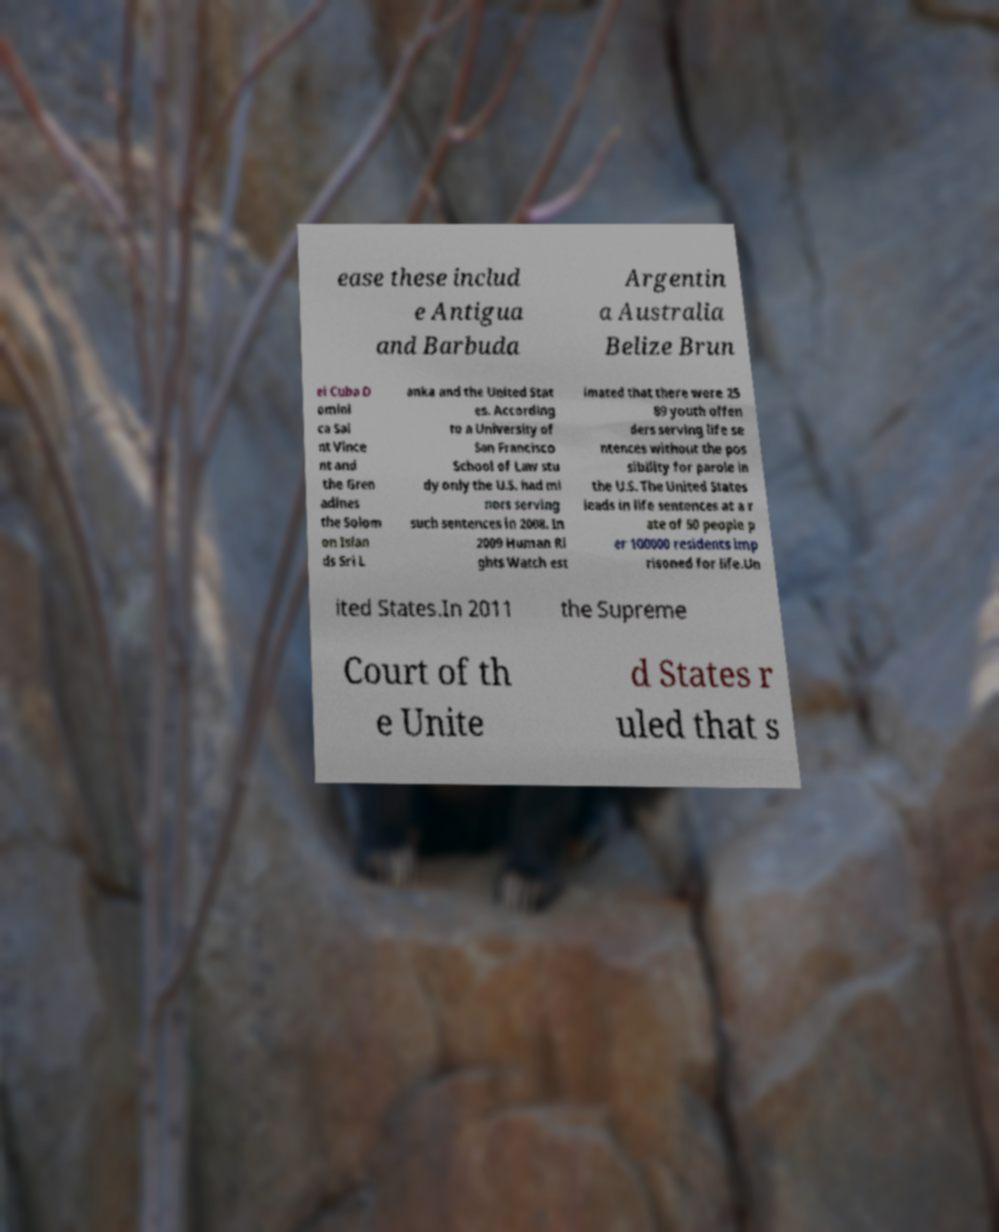Please identify and transcribe the text found in this image. ease these includ e Antigua and Barbuda Argentin a Australia Belize Brun ei Cuba D omini ca Sai nt Vince nt and the Gren adines the Solom on Islan ds Sri L anka and the United Stat es. According to a University of San Francisco School of Law stu dy only the U.S. had mi nors serving such sentences in 2008. In 2009 Human Ri ghts Watch est imated that there were 25 89 youth offen ders serving life se ntences without the pos sibility for parole in the U.S. The United States leads in life sentences at a r ate of 50 people p er 100000 residents imp risoned for life.Un ited States.In 2011 the Supreme Court of th e Unite d States r uled that s 